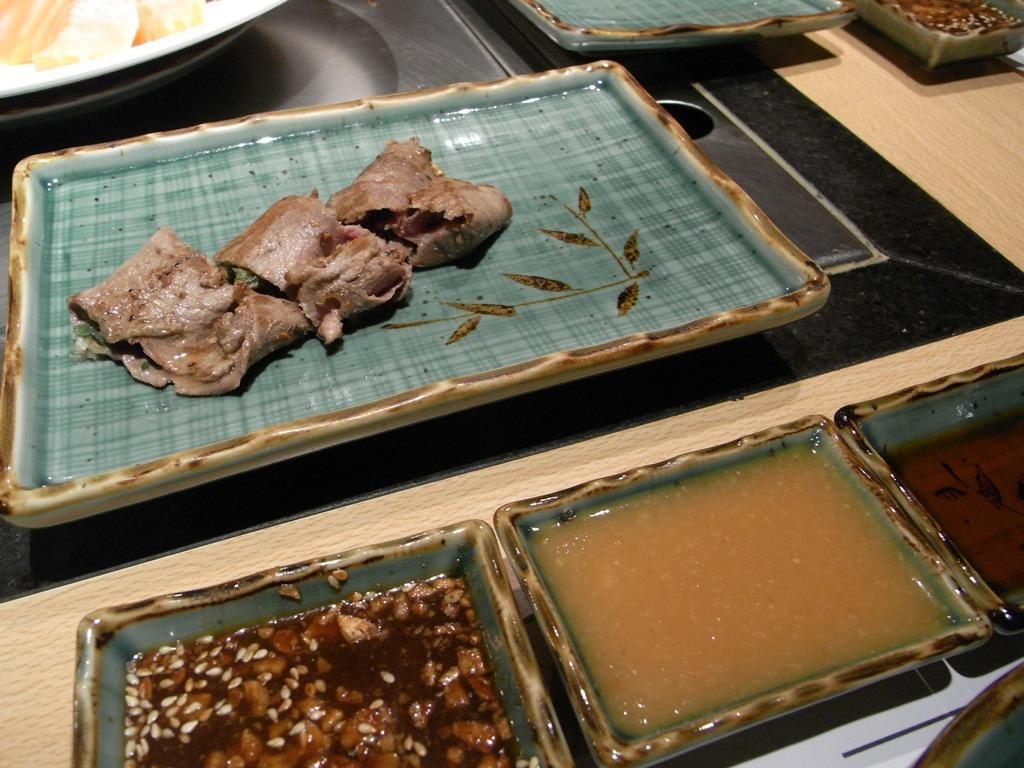Please provide a concise description of this image. In this image we can see a table. On the table there are serving plates with food on them and serving bowls with condiments in them. 